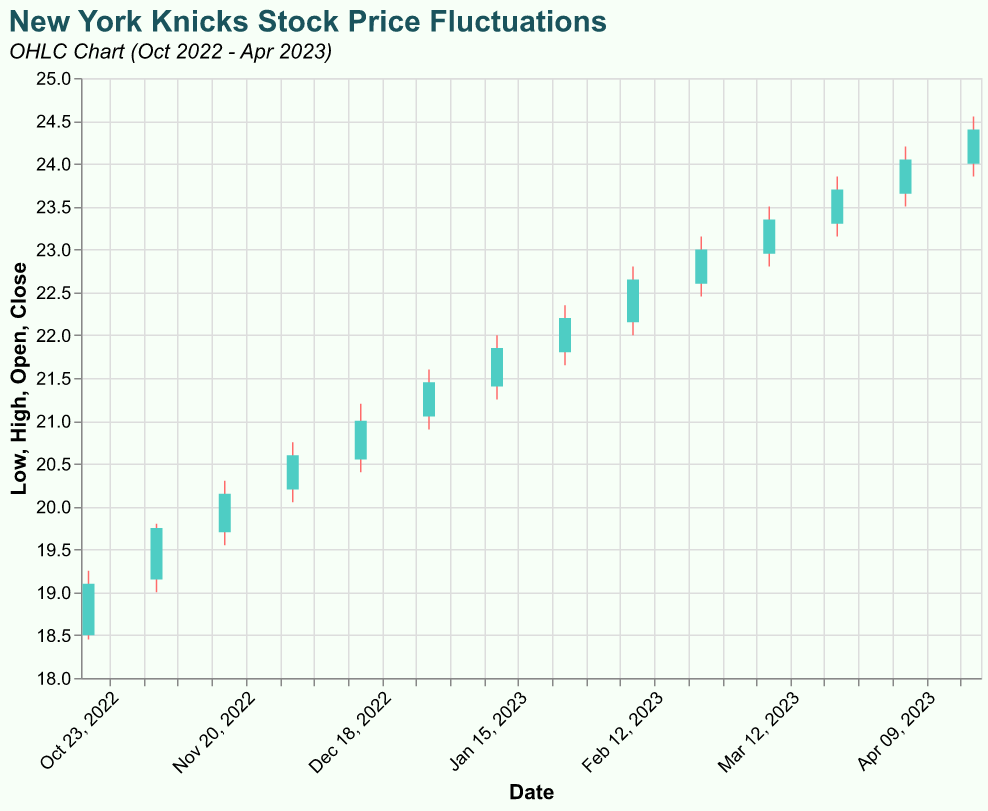What is the title of the chart? The title is positioned at the top of the chart. It reads "New York Knicks Stock Price Fluctuations."
Answer: New York Knicks Stock Price Fluctuations How many data points are shown in the OHLC chart? Count the number of distinct dates along the x-axis. Each date represents one data point.
Answer: 14 Which date has the highest closing price? Look at the y-axis values for the 'Close' and identify the highest one. The date corresponding to this value shows the highest closing price. The highest 'Close' value is 24.40 on 2023-04-19.
Answer: 2023-04-19 What is the range of stock prices (difference between the highest and lowest values) on 2023-04-05? Find the 'High' and 'Low' values for the given date and compute the difference: 24.20 - 23.50 = 0.70
Answer: 0.70 On which date did the stock open at 18.50 and what were the high and low values that day? Locate the date for which 'Open' is 18.50, then note the corresponding 'High' and 'Low' values. For 2022-10-19, 'High' is 19.25 and 'Low' is 18.45.
Answer: 2022-10-19; High: 19.25, Low: 18.45 What is the average closing price over the entire period? Sum all 'Close' prices and then divide by the number of data points (14). Sum = 19.10 + 19.75 + 20.15 + 20.60 + 21.00 + 21.45 + 21.85 + 22.20 + 22.65 + 23.00 + 23.35 + 23.70 + 24.05 + 24.40 = 286.25. Average = 286.25 / 14 ≈ 20.45
Answer: 20.45 Which date showed the smallest difference between the opening and closing prices, and what is the difference? Calculate the difference between 'Open' and 'Close' for each date and identify the smallest difference. The smallest difference is on 2022-10-19 (19.10 - 18.50 = 0.60).
Answer: 2022-10-19; 0.60 During which month did the stock price have the highest fluctuation (highest to lowest range) within a single day? Calculate the difference between 'High' and 'Low' for each date and pick the maximum. The highest fluctuation occurred on 2023-04-19 (24.55 - 23.85 = 0.70).
Answer: April 2023 